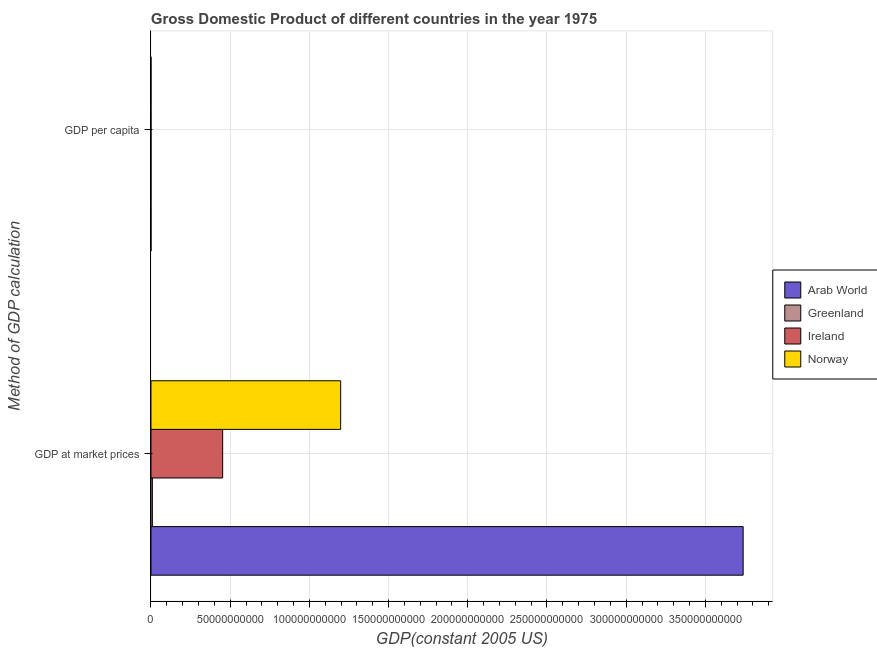How many different coloured bars are there?
Your response must be concise. 4. How many groups of bars are there?
Your answer should be compact. 2. Are the number of bars per tick equal to the number of legend labels?
Ensure brevity in your answer.  Yes. How many bars are there on the 2nd tick from the bottom?
Your response must be concise. 4. What is the label of the 1st group of bars from the top?
Ensure brevity in your answer.  GDP per capita. What is the gdp at market prices in Ireland?
Ensure brevity in your answer.  4.53e+1. Across all countries, what is the maximum gdp at market prices?
Ensure brevity in your answer.  3.74e+11. Across all countries, what is the minimum gdp per capita?
Your response must be concise. 2671.45. In which country was the gdp per capita maximum?
Keep it short and to the point. Norway. In which country was the gdp at market prices minimum?
Offer a terse response. Greenland. What is the total gdp per capita in the graph?
Keep it short and to the point. 6.47e+04. What is the difference between the gdp at market prices in Greenland and that in Ireland?
Your answer should be compact. -4.44e+1. What is the difference between the gdp at market prices in Ireland and the gdp per capita in Norway?
Provide a succinct answer. 4.53e+1. What is the average gdp at market prices per country?
Your answer should be compact. 1.35e+11. What is the difference between the gdp per capita and gdp at market prices in Ireland?
Your response must be concise. -4.53e+1. In how many countries, is the gdp at market prices greater than 70000000000 US$?
Give a very brief answer. 2. What is the ratio of the gdp per capita in Greenland to that in Norway?
Ensure brevity in your answer.  0.6. Is the gdp at market prices in Norway less than that in Arab World?
Your response must be concise. Yes. What does the 3rd bar from the top in GDP per capita represents?
Your response must be concise. Greenland. What does the 1st bar from the bottom in GDP per capita represents?
Make the answer very short. Arab World. Does the graph contain any zero values?
Provide a short and direct response. No. How many legend labels are there?
Provide a short and direct response. 4. How are the legend labels stacked?
Make the answer very short. Vertical. What is the title of the graph?
Offer a terse response. Gross Domestic Product of different countries in the year 1975. Does "Haiti" appear as one of the legend labels in the graph?
Your answer should be compact. No. What is the label or title of the X-axis?
Offer a very short reply. GDP(constant 2005 US). What is the label or title of the Y-axis?
Your answer should be very brief. Method of GDP calculation. What is the GDP(constant 2005 US) in Arab World in GDP at market prices?
Your answer should be compact. 3.74e+11. What is the GDP(constant 2005 US) in Greenland in GDP at market prices?
Your answer should be compact. 8.91e+08. What is the GDP(constant 2005 US) of Ireland in GDP at market prices?
Provide a short and direct response. 4.53e+1. What is the GDP(constant 2005 US) of Norway in GDP at market prices?
Offer a terse response. 1.20e+11. What is the GDP(constant 2005 US) of Arab World in GDP per capita?
Provide a succinct answer. 2671.45. What is the GDP(constant 2005 US) in Greenland in GDP per capita?
Your answer should be compact. 1.80e+04. What is the GDP(constant 2005 US) of Ireland in GDP per capita?
Ensure brevity in your answer.  1.42e+04. What is the GDP(constant 2005 US) of Norway in GDP per capita?
Give a very brief answer. 2.99e+04. Across all Method of GDP calculation, what is the maximum GDP(constant 2005 US) in Arab World?
Keep it short and to the point. 3.74e+11. Across all Method of GDP calculation, what is the maximum GDP(constant 2005 US) in Greenland?
Offer a very short reply. 8.91e+08. Across all Method of GDP calculation, what is the maximum GDP(constant 2005 US) in Ireland?
Offer a terse response. 4.53e+1. Across all Method of GDP calculation, what is the maximum GDP(constant 2005 US) in Norway?
Make the answer very short. 1.20e+11. Across all Method of GDP calculation, what is the minimum GDP(constant 2005 US) in Arab World?
Offer a terse response. 2671.45. Across all Method of GDP calculation, what is the minimum GDP(constant 2005 US) in Greenland?
Keep it short and to the point. 1.80e+04. Across all Method of GDP calculation, what is the minimum GDP(constant 2005 US) in Ireland?
Ensure brevity in your answer.  1.42e+04. Across all Method of GDP calculation, what is the minimum GDP(constant 2005 US) in Norway?
Make the answer very short. 2.99e+04. What is the total GDP(constant 2005 US) of Arab World in the graph?
Provide a short and direct response. 3.74e+11. What is the total GDP(constant 2005 US) of Greenland in the graph?
Your answer should be compact. 8.92e+08. What is the total GDP(constant 2005 US) in Ireland in the graph?
Provide a short and direct response. 4.53e+1. What is the total GDP(constant 2005 US) in Norway in the graph?
Your response must be concise. 1.20e+11. What is the difference between the GDP(constant 2005 US) in Arab World in GDP at market prices and that in GDP per capita?
Offer a terse response. 3.74e+11. What is the difference between the GDP(constant 2005 US) of Greenland in GDP at market prices and that in GDP per capita?
Your answer should be compact. 8.91e+08. What is the difference between the GDP(constant 2005 US) of Ireland in GDP at market prices and that in GDP per capita?
Provide a succinct answer. 4.53e+1. What is the difference between the GDP(constant 2005 US) of Norway in GDP at market prices and that in GDP per capita?
Your answer should be very brief. 1.20e+11. What is the difference between the GDP(constant 2005 US) of Arab World in GDP at market prices and the GDP(constant 2005 US) of Greenland in GDP per capita?
Offer a terse response. 3.74e+11. What is the difference between the GDP(constant 2005 US) in Arab World in GDP at market prices and the GDP(constant 2005 US) in Ireland in GDP per capita?
Provide a succinct answer. 3.74e+11. What is the difference between the GDP(constant 2005 US) in Arab World in GDP at market prices and the GDP(constant 2005 US) in Norway in GDP per capita?
Your response must be concise. 3.74e+11. What is the difference between the GDP(constant 2005 US) in Greenland in GDP at market prices and the GDP(constant 2005 US) in Ireland in GDP per capita?
Keep it short and to the point. 8.91e+08. What is the difference between the GDP(constant 2005 US) in Greenland in GDP at market prices and the GDP(constant 2005 US) in Norway in GDP per capita?
Offer a very short reply. 8.91e+08. What is the difference between the GDP(constant 2005 US) of Ireland in GDP at market prices and the GDP(constant 2005 US) of Norway in GDP per capita?
Make the answer very short. 4.53e+1. What is the average GDP(constant 2005 US) of Arab World per Method of GDP calculation?
Offer a terse response. 1.87e+11. What is the average GDP(constant 2005 US) in Greenland per Method of GDP calculation?
Keep it short and to the point. 4.46e+08. What is the average GDP(constant 2005 US) of Ireland per Method of GDP calculation?
Provide a short and direct response. 2.26e+1. What is the average GDP(constant 2005 US) of Norway per Method of GDP calculation?
Keep it short and to the point. 5.99e+1. What is the difference between the GDP(constant 2005 US) of Arab World and GDP(constant 2005 US) of Greenland in GDP at market prices?
Offer a terse response. 3.73e+11. What is the difference between the GDP(constant 2005 US) in Arab World and GDP(constant 2005 US) in Ireland in GDP at market prices?
Provide a succinct answer. 3.29e+11. What is the difference between the GDP(constant 2005 US) in Arab World and GDP(constant 2005 US) in Norway in GDP at market prices?
Your answer should be compact. 2.54e+11. What is the difference between the GDP(constant 2005 US) in Greenland and GDP(constant 2005 US) in Ireland in GDP at market prices?
Make the answer very short. -4.44e+1. What is the difference between the GDP(constant 2005 US) in Greenland and GDP(constant 2005 US) in Norway in GDP at market prices?
Give a very brief answer. -1.19e+11. What is the difference between the GDP(constant 2005 US) in Ireland and GDP(constant 2005 US) in Norway in GDP at market prices?
Make the answer very short. -7.45e+1. What is the difference between the GDP(constant 2005 US) of Arab World and GDP(constant 2005 US) of Greenland in GDP per capita?
Offer a terse response. -1.53e+04. What is the difference between the GDP(constant 2005 US) of Arab World and GDP(constant 2005 US) of Ireland in GDP per capita?
Provide a succinct answer. -1.15e+04. What is the difference between the GDP(constant 2005 US) of Arab World and GDP(constant 2005 US) of Norway in GDP per capita?
Ensure brevity in your answer.  -2.72e+04. What is the difference between the GDP(constant 2005 US) in Greenland and GDP(constant 2005 US) in Ireland in GDP per capita?
Give a very brief answer. 3783.07. What is the difference between the GDP(constant 2005 US) of Greenland and GDP(constant 2005 US) of Norway in GDP per capita?
Your answer should be very brief. -1.19e+04. What is the difference between the GDP(constant 2005 US) of Ireland and GDP(constant 2005 US) of Norway in GDP per capita?
Make the answer very short. -1.57e+04. What is the ratio of the GDP(constant 2005 US) of Arab World in GDP at market prices to that in GDP per capita?
Your answer should be very brief. 1.40e+08. What is the ratio of the GDP(constant 2005 US) in Greenland in GDP at market prices to that in GDP per capita?
Provide a succinct answer. 4.96e+04. What is the ratio of the GDP(constant 2005 US) of Ireland in GDP at market prices to that in GDP per capita?
Make the answer very short. 3.19e+06. What is the ratio of the GDP(constant 2005 US) of Norway in GDP at market prices to that in GDP per capita?
Your answer should be compact. 4.01e+06. What is the difference between the highest and the second highest GDP(constant 2005 US) in Arab World?
Ensure brevity in your answer.  3.74e+11. What is the difference between the highest and the second highest GDP(constant 2005 US) in Greenland?
Offer a terse response. 8.91e+08. What is the difference between the highest and the second highest GDP(constant 2005 US) in Ireland?
Offer a terse response. 4.53e+1. What is the difference between the highest and the second highest GDP(constant 2005 US) in Norway?
Offer a very short reply. 1.20e+11. What is the difference between the highest and the lowest GDP(constant 2005 US) of Arab World?
Ensure brevity in your answer.  3.74e+11. What is the difference between the highest and the lowest GDP(constant 2005 US) in Greenland?
Your answer should be very brief. 8.91e+08. What is the difference between the highest and the lowest GDP(constant 2005 US) in Ireland?
Your answer should be compact. 4.53e+1. What is the difference between the highest and the lowest GDP(constant 2005 US) of Norway?
Provide a succinct answer. 1.20e+11. 